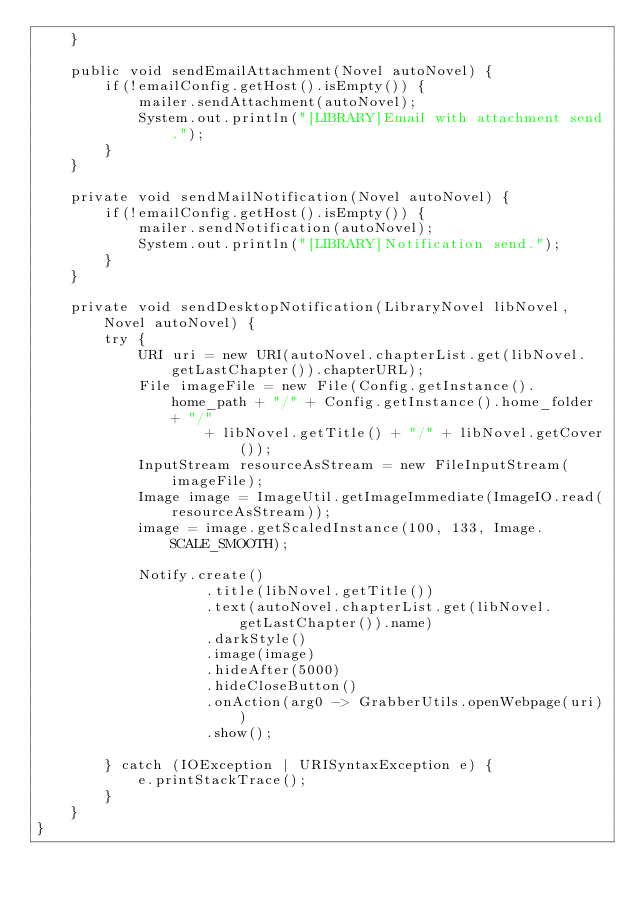<code> <loc_0><loc_0><loc_500><loc_500><_Java_>    }

    public void sendEmailAttachment(Novel autoNovel) {
        if(!emailConfig.getHost().isEmpty()) {
            mailer.sendAttachment(autoNovel);
            System.out.println("[LIBRARY]Email with attachment send.");
        }
    }

    private void sendMailNotification(Novel autoNovel) {
        if(!emailConfig.getHost().isEmpty()) {
            mailer.sendNotification(autoNovel);
            System.out.println("[LIBRARY]Notification send.");
        }
    }

    private void sendDesktopNotification(LibraryNovel libNovel, Novel autoNovel) {
        try {
            URI uri = new URI(autoNovel.chapterList.get(libNovel.getLastChapter()).chapterURL);
            File imageFile = new File(Config.getInstance().home_path + "/" + Config.getInstance().home_folder + "/"
                    + libNovel.getTitle() + "/" + libNovel.getCover());
            InputStream resourceAsStream = new FileInputStream(imageFile);
            Image image = ImageUtil.getImageImmediate(ImageIO.read(resourceAsStream));
            image = image.getScaledInstance(100, 133, Image.SCALE_SMOOTH);

            Notify.create()
                    .title(libNovel.getTitle())
                    .text(autoNovel.chapterList.get(libNovel.getLastChapter()).name)
                    .darkStyle()
                    .image(image)
                    .hideAfter(5000)
                    .hideCloseButton()
                    .onAction(arg0 -> GrabberUtils.openWebpage(uri))
                    .show();

        } catch (IOException | URISyntaxException e) {
            e.printStackTrace();
        }
    }
}
</code> 